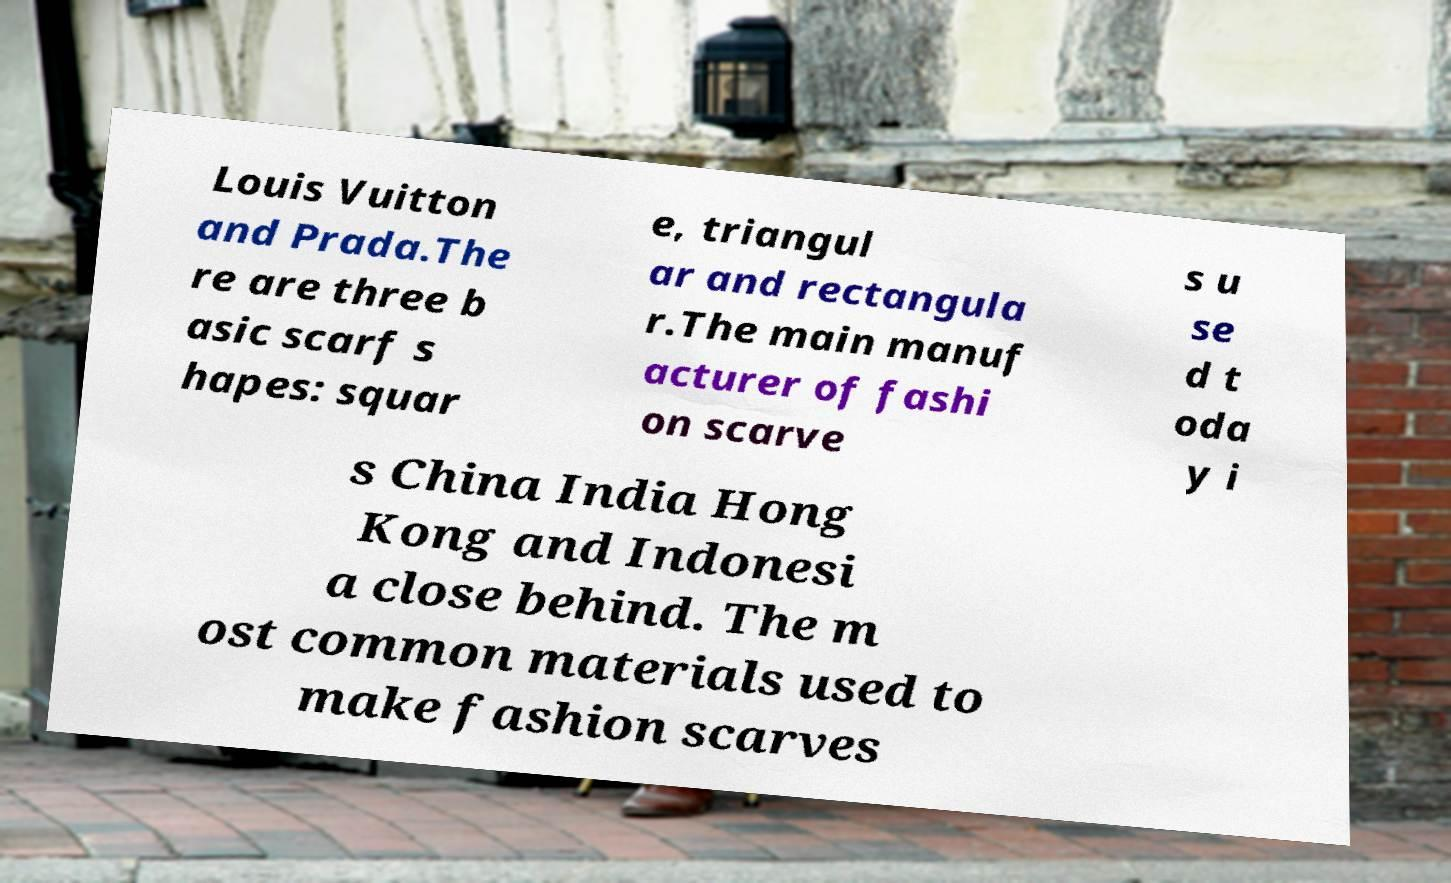Could you assist in decoding the text presented in this image and type it out clearly? Louis Vuitton and Prada.The re are three b asic scarf s hapes: squar e, triangul ar and rectangula r.The main manuf acturer of fashi on scarve s u se d t oda y i s China India Hong Kong and Indonesi a close behind. The m ost common materials used to make fashion scarves 